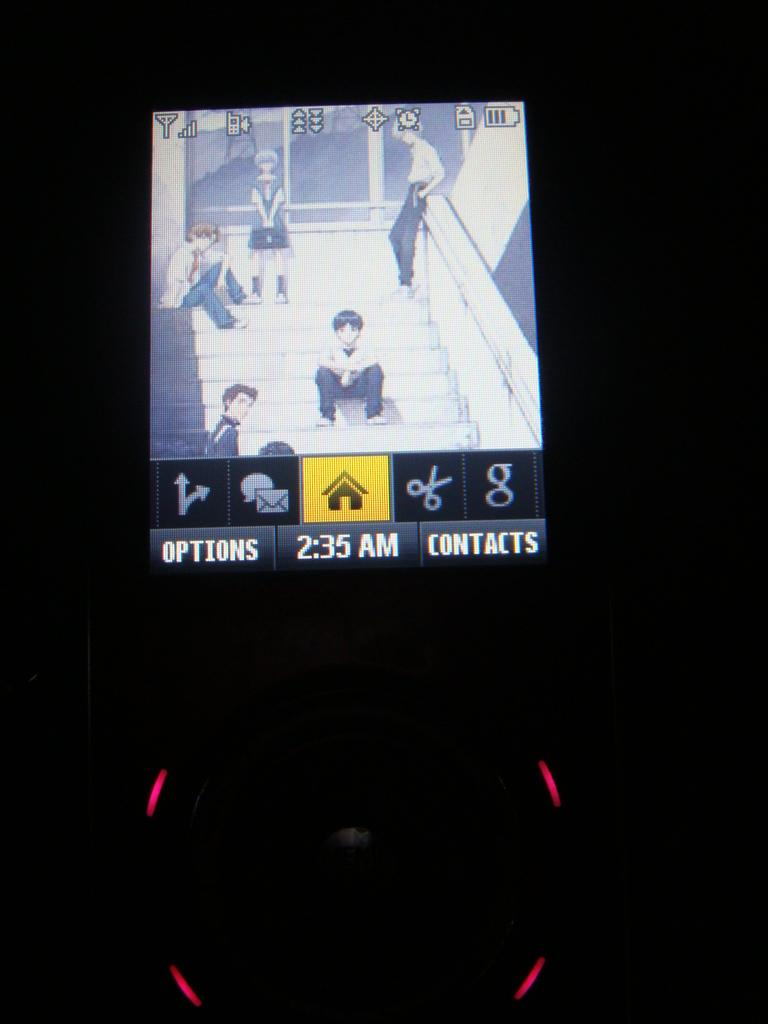What is the main object in the image? There is a screen in the image. What can be seen on the screen? There are people, logos, the time, options, and contacts visible on the screen. Can you describe the people on the screen? The people on the screen are likely participants in a meeting or presentation. What information is displayed on the screen? The screen displays logos, the time, options, and contacts. How many ladybugs can be seen crawling on the screen in the image? There are no ladybugs visible on the screen in the image. What type of passenger is sitting next to the person on the screen? There is no reference to a passenger or any seating arrangement in the image, as it features a screen with various elements displayed. 